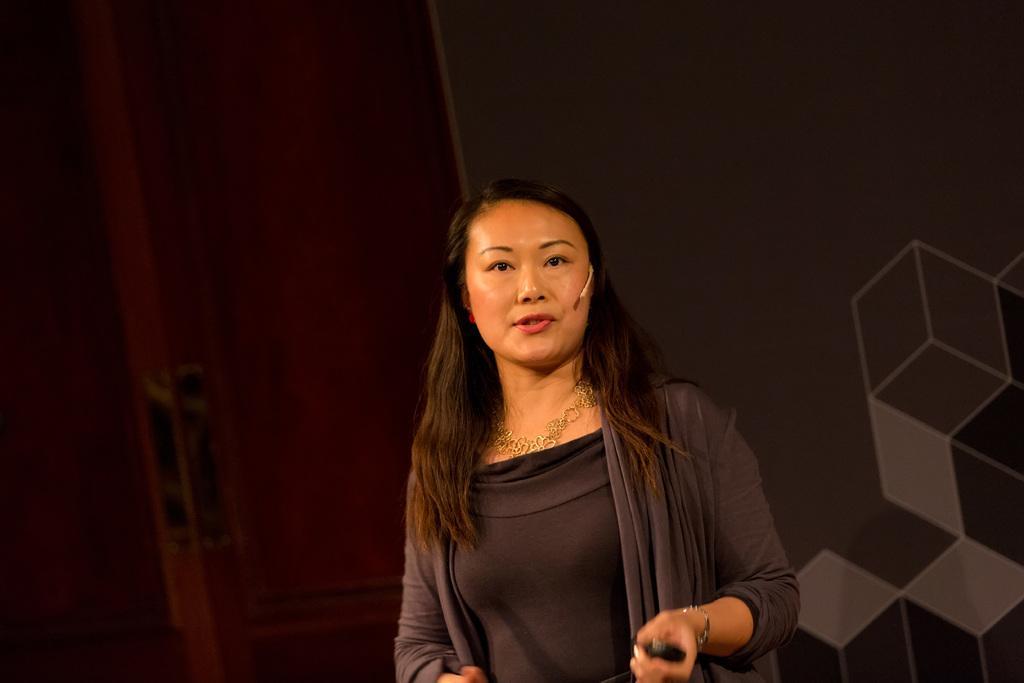Can you describe this image briefly? In the image we can see a woman standing, wearing clothes, neck chain, bracelet and holding an object in hand, and it looks like she is talking. Here we can see microphones and the wall. 